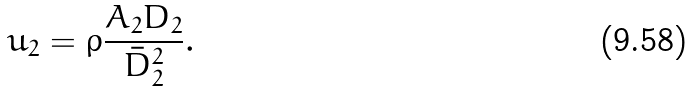<formula> <loc_0><loc_0><loc_500><loc_500>u _ { 2 } = \rho \frac { A _ { 2 } D _ { 2 } } { \bar { D } _ { 2 } ^ { 2 } } .</formula> 